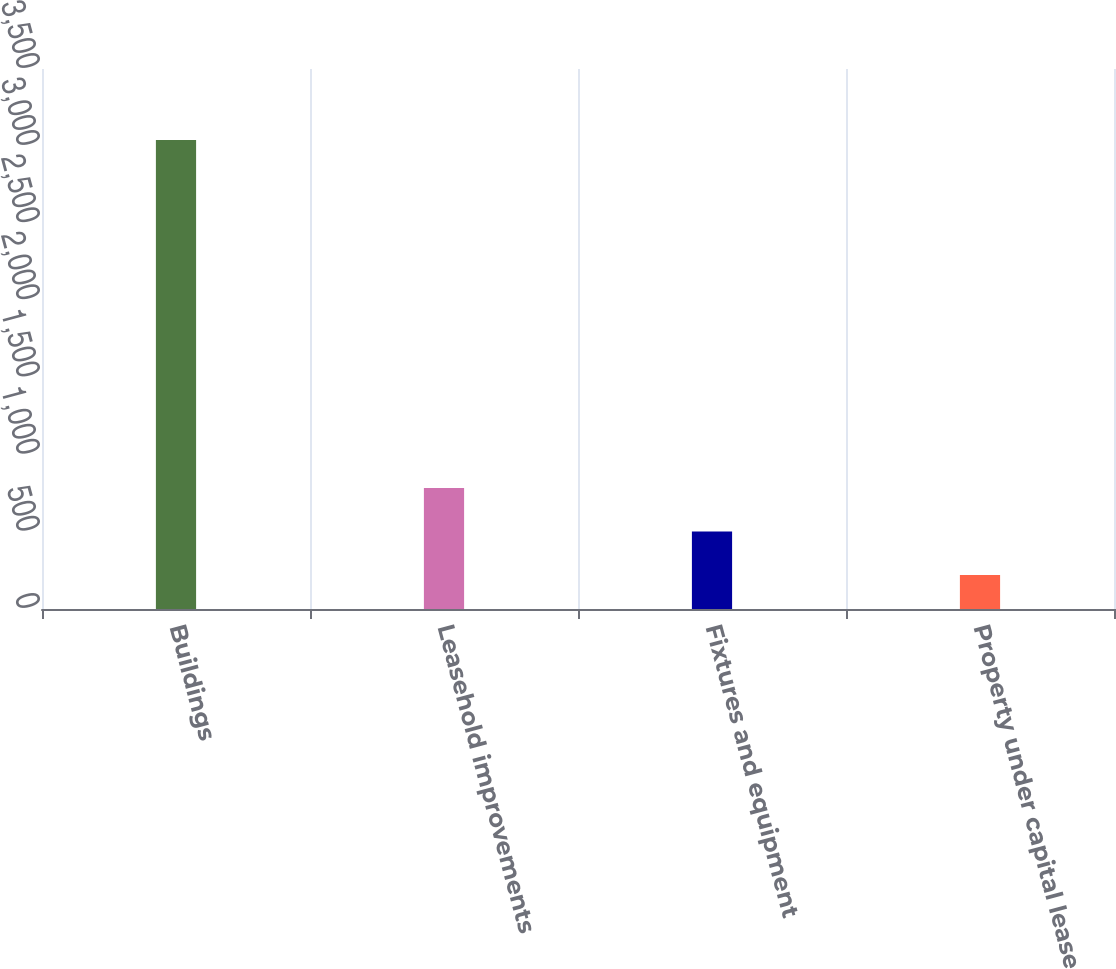<chart> <loc_0><loc_0><loc_500><loc_500><bar_chart><fcel>Buildings<fcel>Leasehold improvements<fcel>Fixtures and equipment<fcel>Property under capital lease<nl><fcel>3040<fcel>784<fcel>502<fcel>220<nl></chart> 